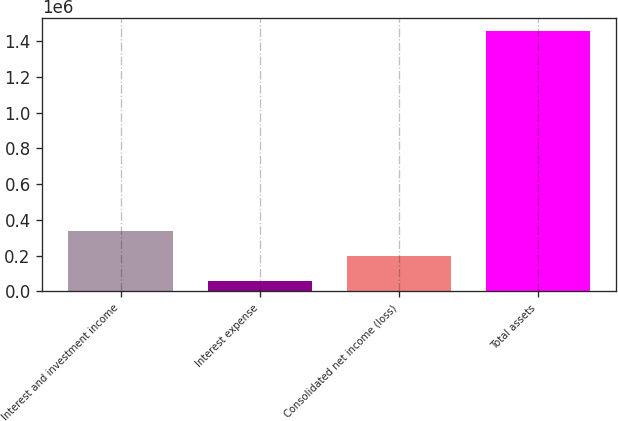Convert chart to OTSL. <chart><loc_0><loc_0><loc_500><loc_500><bar_chart><fcel>Interest and investment income<fcel>Interest expense<fcel>Consolidated net income (loss)<fcel>Total assets<nl><fcel>336541<fcel>56201<fcel>196371<fcel>1.4579e+06<nl></chart> 